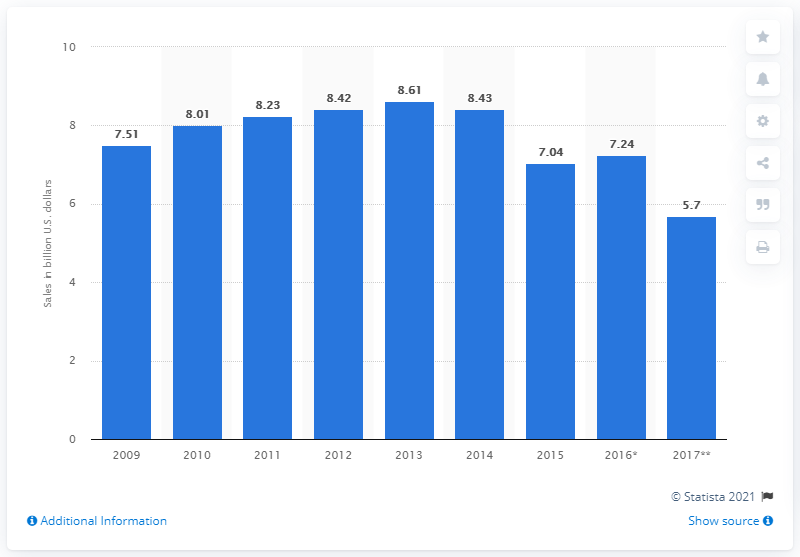Mention a couple of crucial points in this snapshot. The forecast amount of food and drink sales for cafeterias, grill-buffets, and buffets in the U.S. was 5.7. 